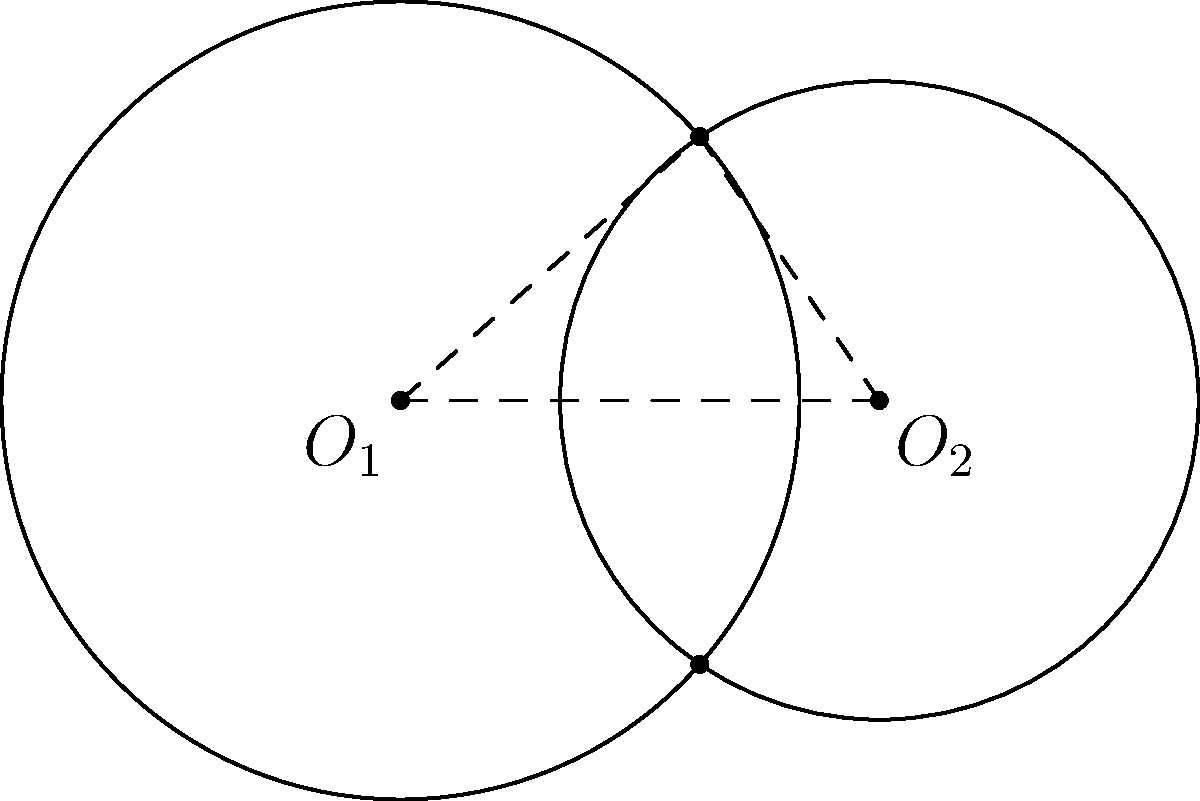As a computer programmer exploring digital media applications, you're developing a data visualization tool for analyzing overlapping sensor ranges. Given two circular sensor ranges with radii $r_1 = 2.5$ units and $r_2 = 2$ units, whose centers are 3 units apart, calculate the area of the overlapping region. Round your answer to two decimal places. To solve this problem, we'll follow these steps:

1) First, we need to find the angle $\theta$ at the center of each circle in the overlapping region.

2) We can use the cosine law to find $\theta$:

   $\cos(\frac{\theta}{2}) = \frac{d^2 + r_1^2 - r_2^2}{2dr_1}$

   Where $d$ is the distance between the centers (3 units).

3) Substituting the values:

   $\cos(\frac{\theta}{2}) = \frac{3^2 + 2.5^2 - 2^2}{2 * 3 * 2.5} = 0.7$

4) Therefore, $\frac{\theta}{2} = \arccos(0.7) = 0.7954$ radians

5) $\theta = 2 * 0.7954 = 1.5908$ radians

6) The area of the overlapping region is the sum of two circular sectors minus two triangles:

   $A = r_1^2 * \theta_1 + r_2^2 * \theta_2 - 2 * \frac{1}{2} * r_1 * r_2 * \sin(\theta)$

7) Where $\theta_1 = \theta_2 = \theta = 1.5908$ radians

8) Substituting the values:

   $A = 2.5^2 * 1.5908 + 2^2 * 1.5908 - 2.5 * 2 * \sin(1.5908)$

9) Calculating:

   $A = 9.9425 + 6.3632 - 3.7082 = 12.5975$ square units

10) Rounding to two decimal places: 12.60 square units
Answer: 12.60 square units 